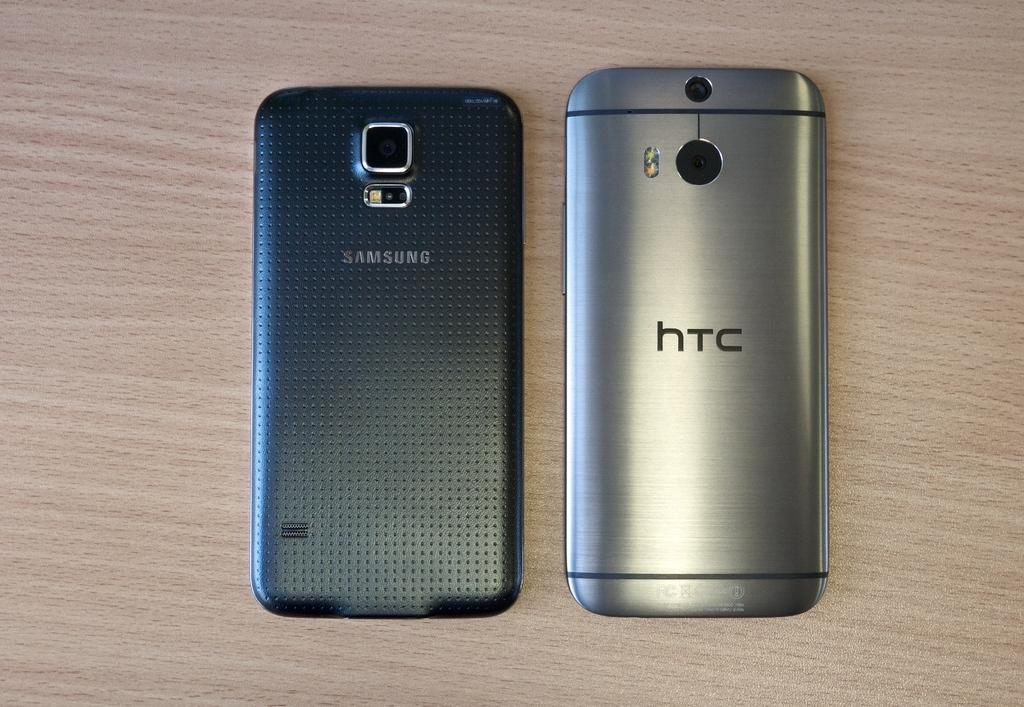<image>
Summarize the visual content of the image. A black Samsung and a silver HTC phone 